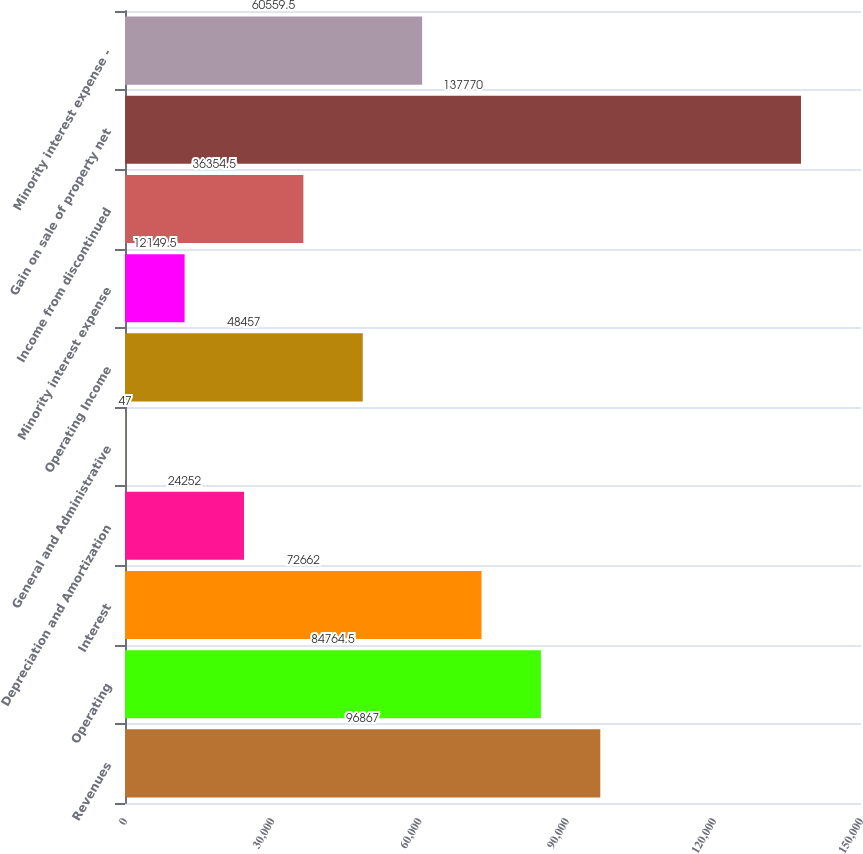Convert chart. <chart><loc_0><loc_0><loc_500><loc_500><bar_chart><fcel>Revenues<fcel>Operating<fcel>Interest<fcel>Depreciation and Amortization<fcel>General and Administrative<fcel>Operating Income<fcel>Minority interest expense<fcel>Income from discontinued<fcel>Gain on sale of property net<fcel>Minority interest expense -<nl><fcel>96867<fcel>84764.5<fcel>72662<fcel>24252<fcel>47<fcel>48457<fcel>12149.5<fcel>36354.5<fcel>137770<fcel>60559.5<nl></chart> 